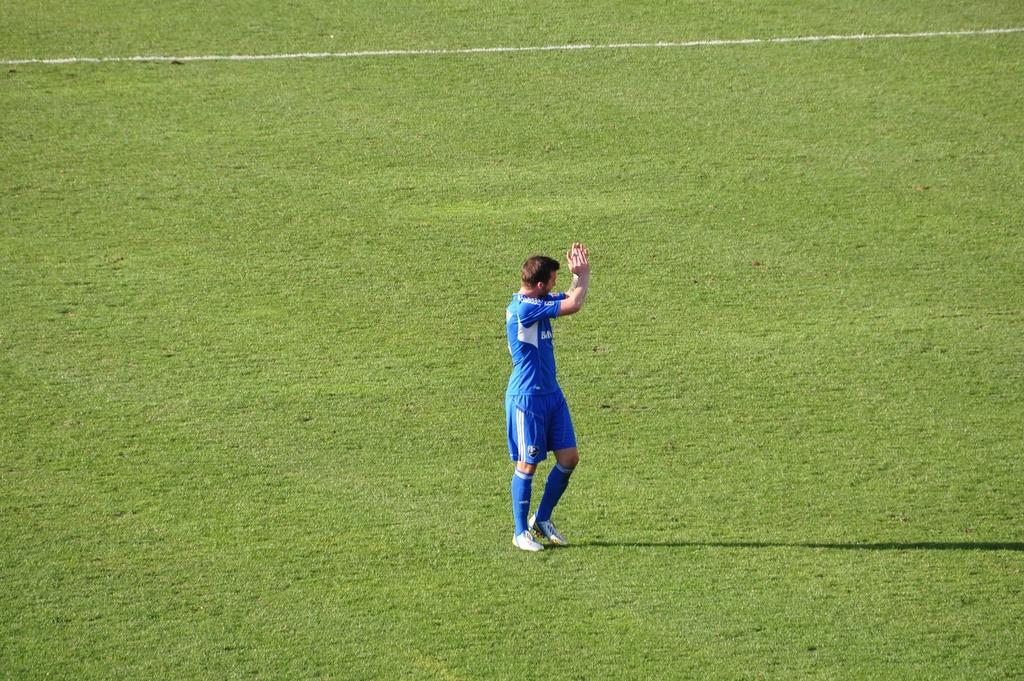What is the person in the image wearing? The person is wearing a blue color dress in the image. What is the person doing in the image? The person is clapping in the image. Where is the person located in the image? The person is on the grass on the ground in the image. What can be seen in the background of the image? There is a white color line and grass in the background of the image. What type of animal is the person cooking in the image? There is no animal or cooking activity present in the image. What color is the chalk used to draw the line in the background of the image? There is no chalk visible in the image; only a white color line is mentioned in the background. 